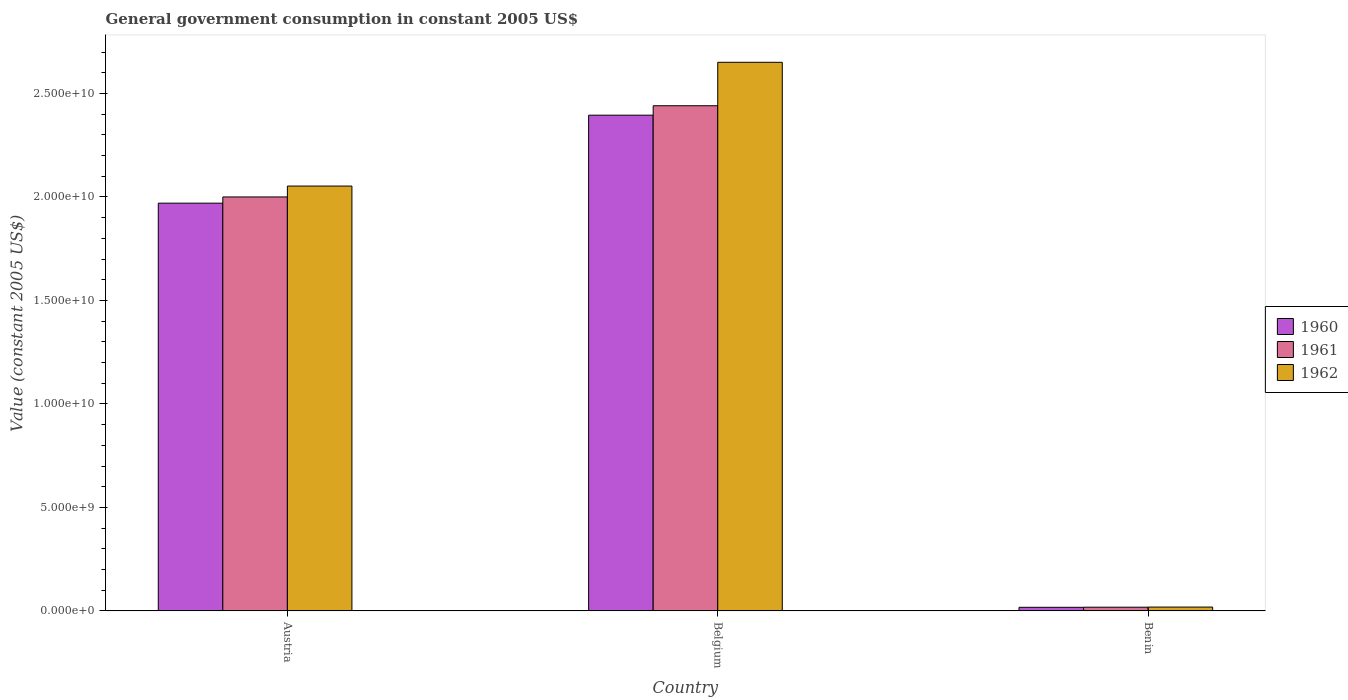Are the number of bars per tick equal to the number of legend labels?
Ensure brevity in your answer.  Yes. Are the number of bars on each tick of the X-axis equal?
Offer a very short reply. Yes. In how many cases, is the number of bars for a given country not equal to the number of legend labels?
Ensure brevity in your answer.  0. What is the government conusmption in 1961 in Belgium?
Provide a short and direct response. 2.44e+1. Across all countries, what is the maximum government conusmption in 1962?
Make the answer very short. 2.65e+1. Across all countries, what is the minimum government conusmption in 1961?
Ensure brevity in your answer.  1.79e+08. In which country was the government conusmption in 1960 minimum?
Provide a succinct answer. Benin. What is the total government conusmption in 1960 in the graph?
Provide a short and direct response. 4.38e+1. What is the difference between the government conusmption in 1962 in Belgium and that in Benin?
Make the answer very short. 2.63e+1. What is the difference between the government conusmption in 1961 in Benin and the government conusmption in 1962 in Austria?
Offer a terse response. -2.03e+1. What is the average government conusmption in 1961 per country?
Ensure brevity in your answer.  1.49e+1. What is the difference between the government conusmption of/in 1960 and government conusmption of/in 1962 in Austria?
Keep it short and to the point. -8.27e+08. What is the ratio of the government conusmption in 1960 in Austria to that in Benin?
Make the answer very short. 113.66. Is the difference between the government conusmption in 1960 in Austria and Benin greater than the difference between the government conusmption in 1962 in Austria and Benin?
Make the answer very short. No. What is the difference between the highest and the second highest government conusmption in 1960?
Your response must be concise. 2.38e+1. What is the difference between the highest and the lowest government conusmption in 1962?
Your answer should be compact. 2.63e+1. What does the 1st bar from the left in Benin represents?
Offer a very short reply. 1960. What does the 1st bar from the right in Belgium represents?
Your response must be concise. 1962. How many bars are there?
Keep it short and to the point. 9. Are all the bars in the graph horizontal?
Make the answer very short. No. How many countries are there in the graph?
Provide a succinct answer. 3. Are the values on the major ticks of Y-axis written in scientific E-notation?
Ensure brevity in your answer.  Yes. Does the graph contain any zero values?
Your answer should be very brief. No. Does the graph contain grids?
Your answer should be compact. No. How many legend labels are there?
Provide a short and direct response. 3. What is the title of the graph?
Keep it short and to the point. General government consumption in constant 2005 US$. Does "2006" appear as one of the legend labels in the graph?
Offer a very short reply. No. What is the label or title of the X-axis?
Offer a very short reply. Country. What is the label or title of the Y-axis?
Your answer should be very brief. Value (constant 2005 US$). What is the Value (constant 2005 US$) of 1960 in Austria?
Offer a very short reply. 1.97e+1. What is the Value (constant 2005 US$) of 1961 in Austria?
Make the answer very short. 2.00e+1. What is the Value (constant 2005 US$) of 1962 in Austria?
Make the answer very short. 2.05e+1. What is the Value (constant 2005 US$) in 1960 in Belgium?
Make the answer very short. 2.40e+1. What is the Value (constant 2005 US$) in 1961 in Belgium?
Give a very brief answer. 2.44e+1. What is the Value (constant 2005 US$) in 1962 in Belgium?
Your response must be concise. 2.65e+1. What is the Value (constant 2005 US$) of 1960 in Benin?
Provide a short and direct response. 1.73e+08. What is the Value (constant 2005 US$) in 1961 in Benin?
Give a very brief answer. 1.79e+08. What is the Value (constant 2005 US$) of 1962 in Benin?
Provide a succinct answer. 1.85e+08. Across all countries, what is the maximum Value (constant 2005 US$) in 1960?
Your answer should be very brief. 2.40e+1. Across all countries, what is the maximum Value (constant 2005 US$) of 1961?
Provide a succinct answer. 2.44e+1. Across all countries, what is the maximum Value (constant 2005 US$) of 1962?
Offer a very short reply. 2.65e+1. Across all countries, what is the minimum Value (constant 2005 US$) in 1960?
Offer a very short reply. 1.73e+08. Across all countries, what is the minimum Value (constant 2005 US$) in 1961?
Ensure brevity in your answer.  1.79e+08. Across all countries, what is the minimum Value (constant 2005 US$) of 1962?
Give a very brief answer. 1.85e+08. What is the total Value (constant 2005 US$) of 1960 in the graph?
Offer a terse response. 4.38e+1. What is the total Value (constant 2005 US$) in 1961 in the graph?
Give a very brief answer. 4.46e+1. What is the total Value (constant 2005 US$) in 1962 in the graph?
Ensure brevity in your answer.  4.72e+1. What is the difference between the Value (constant 2005 US$) of 1960 in Austria and that in Belgium?
Ensure brevity in your answer.  -4.25e+09. What is the difference between the Value (constant 2005 US$) in 1961 in Austria and that in Belgium?
Give a very brief answer. -4.41e+09. What is the difference between the Value (constant 2005 US$) of 1962 in Austria and that in Belgium?
Your answer should be compact. -5.98e+09. What is the difference between the Value (constant 2005 US$) in 1960 in Austria and that in Benin?
Give a very brief answer. 1.95e+1. What is the difference between the Value (constant 2005 US$) of 1961 in Austria and that in Benin?
Offer a terse response. 1.98e+1. What is the difference between the Value (constant 2005 US$) of 1962 in Austria and that in Benin?
Provide a succinct answer. 2.03e+1. What is the difference between the Value (constant 2005 US$) of 1960 in Belgium and that in Benin?
Your answer should be very brief. 2.38e+1. What is the difference between the Value (constant 2005 US$) of 1961 in Belgium and that in Benin?
Your answer should be compact. 2.42e+1. What is the difference between the Value (constant 2005 US$) of 1962 in Belgium and that in Benin?
Ensure brevity in your answer.  2.63e+1. What is the difference between the Value (constant 2005 US$) in 1960 in Austria and the Value (constant 2005 US$) in 1961 in Belgium?
Offer a terse response. -4.71e+09. What is the difference between the Value (constant 2005 US$) of 1960 in Austria and the Value (constant 2005 US$) of 1962 in Belgium?
Make the answer very short. -6.81e+09. What is the difference between the Value (constant 2005 US$) in 1961 in Austria and the Value (constant 2005 US$) in 1962 in Belgium?
Your answer should be very brief. -6.51e+09. What is the difference between the Value (constant 2005 US$) of 1960 in Austria and the Value (constant 2005 US$) of 1961 in Benin?
Provide a succinct answer. 1.95e+1. What is the difference between the Value (constant 2005 US$) of 1960 in Austria and the Value (constant 2005 US$) of 1962 in Benin?
Make the answer very short. 1.95e+1. What is the difference between the Value (constant 2005 US$) in 1961 in Austria and the Value (constant 2005 US$) in 1962 in Benin?
Provide a short and direct response. 1.98e+1. What is the difference between the Value (constant 2005 US$) of 1960 in Belgium and the Value (constant 2005 US$) of 1961 in Benin?
Give a very brief answer. 2.38e+1. What is the difference between the Value (constant 2005 US$) of 1960 in Belgium and the Value (constant 2005 US$) of 1962 in Benin?
Your answer should be very brief. 2.38e+1. What is the difference between the Value (constant 2005 US$) in 1961 in Belgium and the Value (constant 2005 US$) in 1962 in Benin?
Ensure brevity in your answer.  2.42e+1. What is the average Value (constant 2005 US$) in 1960 per country?
Your answer should be very brief. 1.46e+1. What is the average Value (constant 2005 US$) of 1961 per country?
Offer a terse response. 1.49e+1. What is the average Value (constant 2005 US$) of 1962 per country?
Provide a short and direct response. 1.57e+1. What is the difference between the Value (constant 2005 US$) in 1960 and Value (constant 2005 US$) in 1961 in Austria?
Offer a very short reply. -3.01e+08. What is the difference between the Value (constant 2005 US$) in 1960 and Value (constant 2005 US$) in 1962 in Austria?
Your response must be concise. -8.27e+08. What is the difference between the Value (constant 2005 US$) of 1961 and Value (constant 2005 US$) of 1962 in Austria?
Keep it short and to the point. -5.26e+08. What is the difference between the Value (constant 2005 US$) in 1960 and Value (constant 2005 US$) in 1961 in Belgium?
Keep it short and to the point. -4.56e+08. What is the difference between the Value (constant 2005 US$) of 1960 and Value (constant 2005 US$) of 1962 in Belgium?
Offer a terse response. -2.55e+09. What is the difference between the Value (constant 2005 US$) in 1961 and Value (constant 2005 US$) in 1962 in Belgium?
Make the answer very short. -2.10e+09. What is the difference between the Value (constant 2005 US$) of 1960 and Value (constant 2005 US$) of 1961 in Benin?
Provide a succinct answer. -5.64e+06. What is the difference between the Value (constant 2005 US$) in 1960 and Value (constant 2005 US$) in 1962 in Benin?
Offer a very short reply. -1.13e+07. What is the difference between the Value (constant 2005 US$) of 1961 and Value (constant 2005 US$) of 1962 in Benin?
Offer a very short reply. -5.64e+06. What is the ratio of the Value (constant 2005 US$) in 1960 in Austria to that in Belgium?
Ensure brevity in your answer.  0.82. What is the ratio of the Value (constant 2005 US$) of 1961 in Austria to that in Belgium?
Your answer should be compact. 0.82. What is the ratio of the Value (constant 2005 US$) in 1962 in Austria to that in Belgium?
Your response must be concise. 0.77. What is the ratio of the Value (constant 2005 US$) in 1960 in Austria to that in Benin?
Offer a very short reply. 113.66. What is the ratio of the Value (constant 2005 US$) in 1961 in Austria to that in Benin?
Make the answer very short. 111.76. What is the ratio of the Value (constant 2005 US$) in 1962 in Austria to that in Benin?
Offer a terse response. 111.2. What is the ratio of the Value (constant 2005 US$) in 1960 in Belgium to that in Benin?
Keep it short and to the point. 138.18. What is the ratio of the Value (constant 2005 US$) of 1961 in Belgium to that in Benin?
Give a very brief answer. 136.38. What is the ratio of the Value (constant 2005 US$) of 1962 in Belgium to that in Benin?
Your response must be concise. 143.58. What is the difference between the highest and the second highest Value (constant 2005 US$) in 1960?
Offer a very short reply. 4.25e+09. What is the difference between the highest and the second highest Value (constant 2005 US$) of 1961?
Your answer should be very brief. 4.41e+09. What is the difference between the highest and the second highest Value (constant 2005 US$) in 1962?
Give a very brief answer. 5.98e+09. What is the difference between the highest and the lowest Value (constant 2005 US$) of 1960?
Offer a terse response. 2.38e+1. What is the difference between the highest and the lowest Value (constant 2005 US$) in 1961?
Ensure brevity in your answer.  2.42e+1. What is the difference between the highest and the lowest Value (constant 2005 US$) in 1962?
Your answer should be very brief. 2.63e+1. 